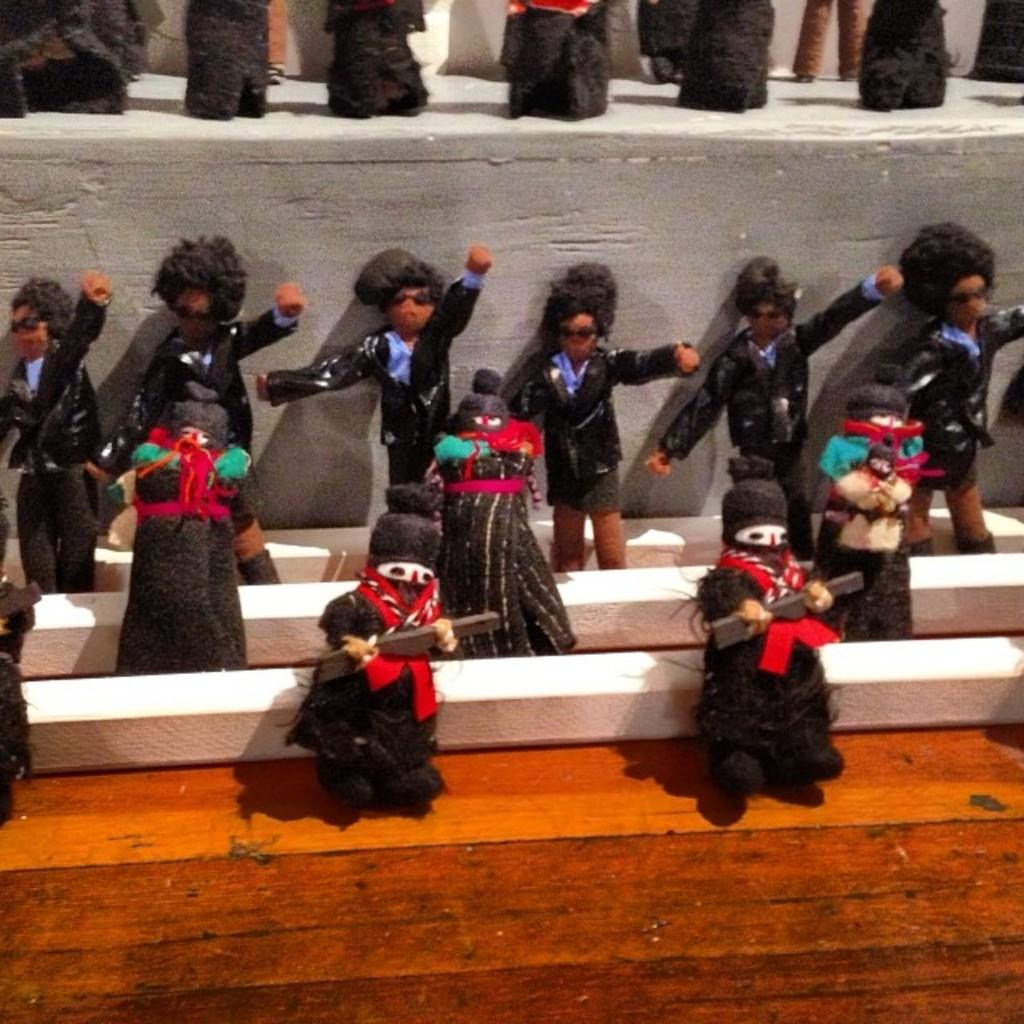What type of objects can be seen in the image? There are toys in the image. What colors are the toys? The toys are in black, purple, and red colors. What is the surface on which the toys are placed? The toys are on a brown color surface. What can be seen in the background of the image? There is an ash color wall in the background of the image. What type of bottle is placed on the wall in the image? There is no bottle present in the image; it only features toys on a brown surface with an ash color wall in the background. 